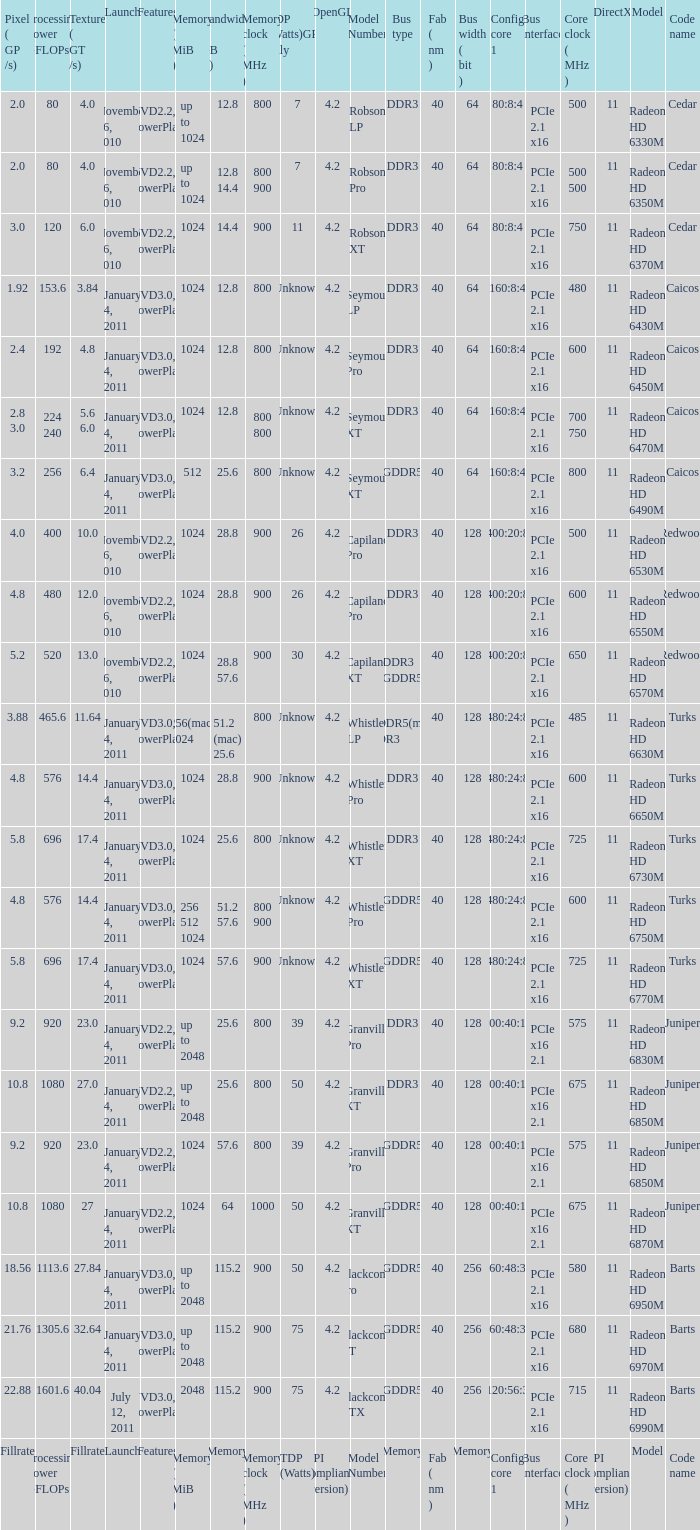How many values for fab(nm) if the model number is Whistler LP? 1.0. 